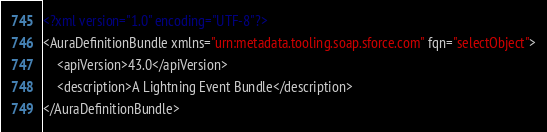Convert code to text. <code><loc_0><loc_0><loc_500><loc_500><_XML_><?xml version="1.0" encoding="UTF-8"?>
<AuraDefinitionBundle xmlns="urn:metadata.tooling.soap.sforce.com" fqn="selectObject">
    <apiVersion>43.0</apiVersion>
    <description>A Lightning Event Bundle</description>
</AuraDefinitionBundle>
</code> 